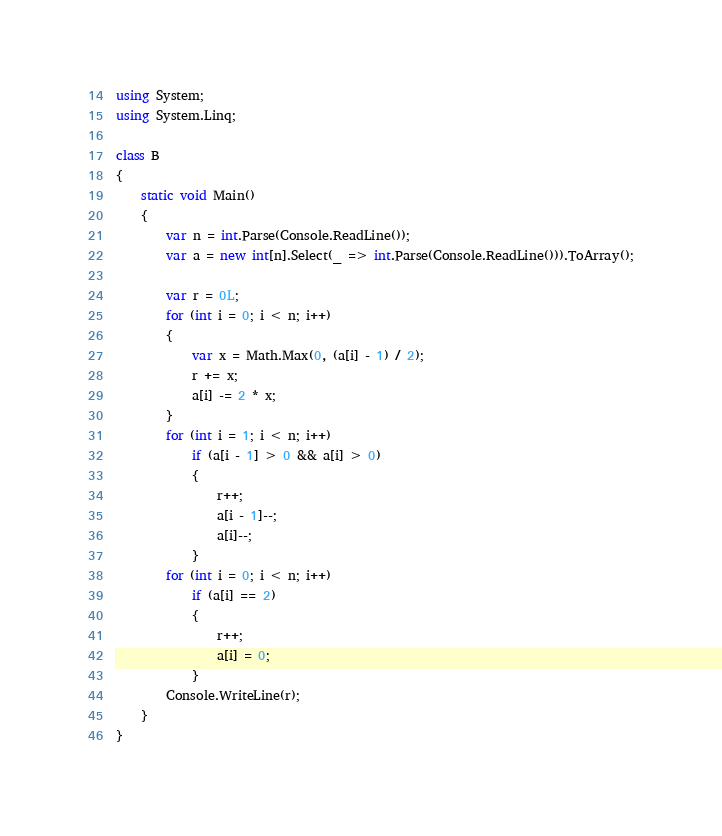Convert code to text. <code><loc_0><loc_0><loc_500><loc_500><_C#_>using System;
using System.Linq;

class B
{
	static void Main()
	{
		var n = int.Parse(Console.ReadLine());
		var a = new int[n].Select(_ => int.Parse(Console.ReadLine())).ToArray();

		var r = 0L;
		for (int i = 0; i < n; i++)
		{
			var x = Math.Max(0, (a[i] - 1) / 2);
			r += x;
			a[i] -= 2 * x;
		}
		for (int i = 1; i < n; i++)
			if (a[i - 1] > 0 && a[i] > 0)
			{
				r++;
				a[i - 1]--;
				a[i]--;
			}
		for (int i = 0; i < n; i++)
			if (a[i] == 2)
			{
				r++;
				a[i] = 0;
			}
		Console.WriteLine(r);
	}
}
</code> 